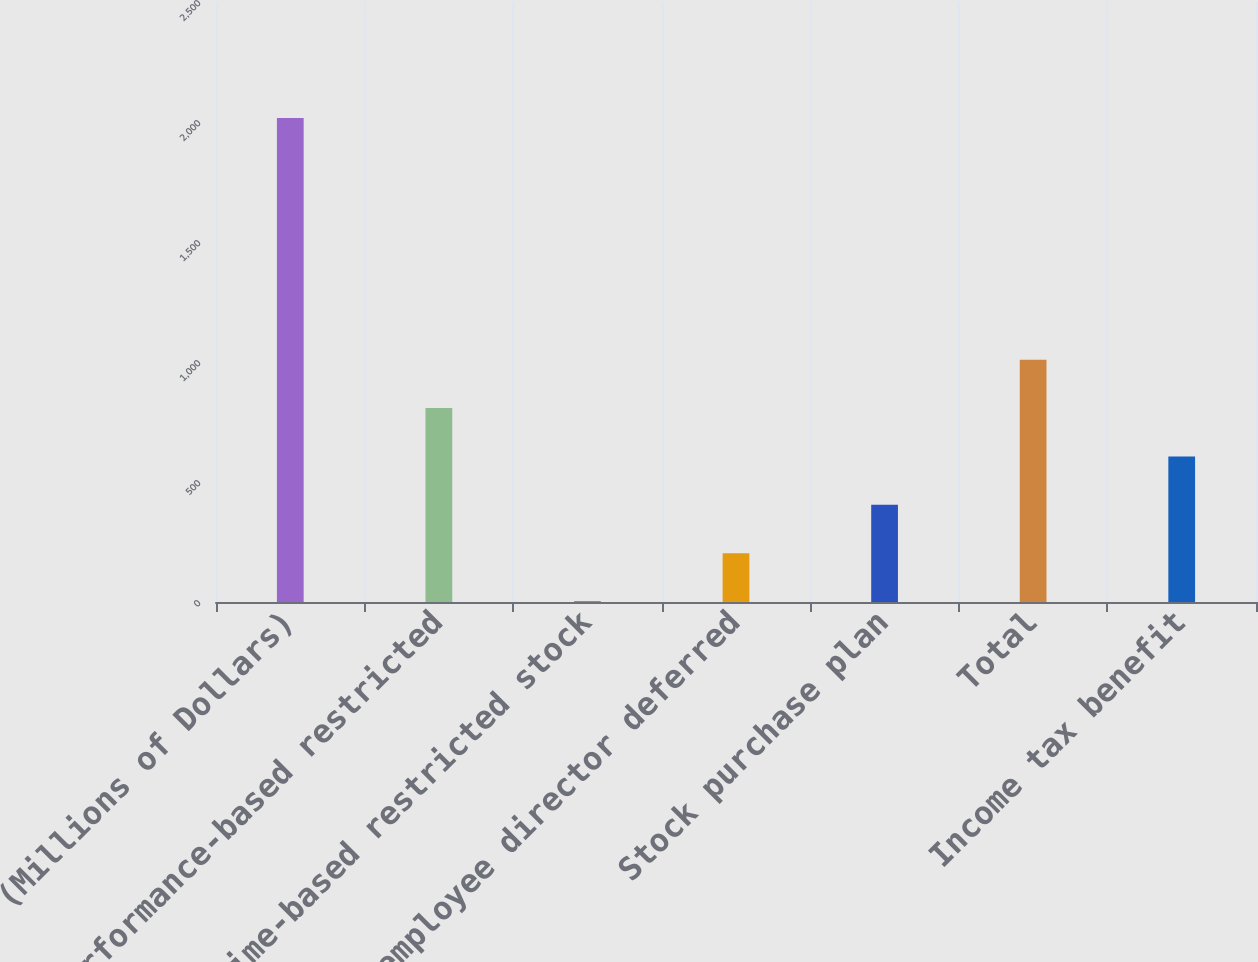Convert chart to OTSL. <chart><loc_0><loc_0><loc_500><loc_500><bar_chart><fcel>(Millions of Dollars)<fcel>Performance-based restricted<fcel>Time-based restricted stock<fcel>Non-employee director deferred<fcel>Stock purchase plan<fcel>Total<fcel>Income tax benefit<nl><fcel>2017<fcel>808<fcel>2<fcel>203.5<fcel>405<fcel>1009.5<fcel>606.5<nl></chart> 